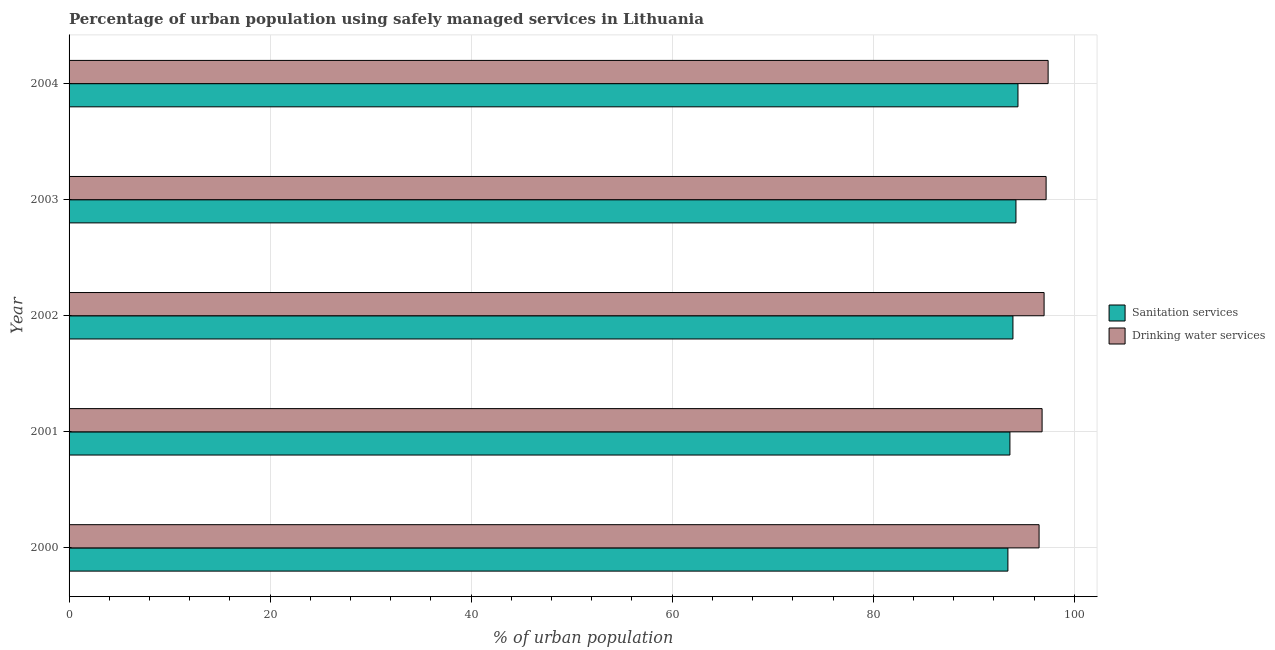How many different coloured bars are there?
Offer a very short reply. 2. How many groups of bars are there?
Make the answer very short. 5. What is the percentage of urban population who used sanitation services in 2002?
Make the answer very short. 93.9. Across all years, what is the maximum percentage of urban population who used drinking water services?
Provide a short and direct response. 97.4. Across all years, what is the minimum percentage of urban population who used drinking water services?
Provide a short and direct response. 96.5. What is the total percentage of urban population who used drinking water services in the graph?
Keep it short and to the point. 484.9. What is the difference between the percentage of urban population who used drinking water services in 2003 and that in 2004?
Ensure brevity in your answer.  -0.2. What is the difference between the percentage of urban population who used sanitation services in 2004 and the percentage of urban population who used drinking water services in 2003?
Offer a very short reply. -2.8. What is the average percentage of urban population who used drinking water services per year?
Offer a terse response. 96.98. In how many years, is the percentage of urban population who used sanitation services greater than 96 %?
Provide a short and direct response. 0. What is the ratio of the percentage of urban population who used sanitation services in 2001 to that in 2004?
Give a very brief answer. 0.99. Is the percentage of urban population who used drinking water services in 2000 less than that in 2001?
Keep it short and to the point. Yes. What is the difference between the highest and the second highest percentage of urban population who used drinking water services?
Offer a terse response. 0.2. What is the difference between the highest and the lowest percentage of urban population who used drinking water services?
Give a very brief answer. 0.9. Is the sum of the percentage of urban population who used drinking water services in 2000 and 2001 greater than the maximum percentage of urban population who used sanitation services across all years?
Your answer should be compact. Yes. What does the 2nd bar from the top in 2001 represents?
Ensure brevity in your answer.  Sanitation services. What does the 2nd bar from the bottom in 2001 represents?
Make the answer very short. Drinking water services. How many years are there in the graph?
Your answer should be compact. 5. What is the difference between two consecutive major ticks on the X-axis?
Offer a terse response. 20. Does the graph contain any zero values?
Offer a terse response. No. How many legend labels are there?
Your answer should be very brief. 2. How are the legend labels stacked?
Ensure brevity in your answer.  Vertical. What is the title of the graph?
Your answer should be compact. Percentage of urban population using safely managed services in Lithuania. Does "Start a business" appear as one of the legend labels in the graph?
Provide a succinct answer. No. What is the label or title of the X-axis?
Provide a short and direct response. % of urban population. What is the % of urban population in Sanitation services in 2000?
Provide a succinct answer. 93.4. What is the % of urban population in Drinking water services in 2000?
Your answer should be compact. 96.5. What is the % of urban population in Sanitation services in 2001?
Give a very brief answer. 93.6. What is the % of urban population in Drinking water services in 2001?
Provide a short and direct response. 96.8. What is the % of urban population in Sanitation services in 2002?
Your response must be concise. 93.9. What is the % of urban population of Drinking water services in 2002?
Your answer should be compact. 97. What is the % of urban population in Sanitation services in 2003?
Keep it short and to the point. 94.2. What is the % of urban population of Drinking water services in 2003?
Make the answer very short. 97.2. What is the % of urban population in Sanitation services in 2004?
Offer a very short reply. 94.4. What is the % of urban population in Drinking water services in 2004?
Provide a short and direct response. 97.4. Across all years, what is the maximum % of urban population of Sanitation services?
Your answer should be very brief. 94.4. Across all years, what is the maximum % of urban population in Drinking water services?
Keep it short and to the point. 97.4. Across all years, what is the minimum % of urban population in Sanitation services?
Provide a short and direct response. 93.4. Across all years, what is the minimum % of urban population in Drinking water services?
Your answer should be very brief. 96.5. What is the total % of urban population in Sanitation services in the graph?
Your answer should be very brief. 469.5. What is the total % of urban population of Drinking water services in the graph?
Your response must be concise. 484.9. What is the difference between the % of urban population in Sanitation services in 2000 and that in 2002?
Provide a succinct answer. -0.5. What is the difference between the % of urban population in Drinking water services in 2000 and that in 2002?
Provide a short and direct response. -0.5. What is the difference between the % of urban population in Drinking water services in 2000 and that in 2004?
Your answer should be compact. -0.9. What is the difference between the % of urban population of Sanitation services in 2001 and that in 2004?
Provide a short and direct response. -0.8. What is the difference between the % of urban population in Sanitation services in 2002 and that in 2003?
Offer a terse response. -0.3. What is the difference between the % of urban population of Drinking water services in 2002 and that in 2003?
Provide a succinct answer. -0.2. What is the difference between the % of urban population in Sanitation services in 2000 and the % of urban population in Drinking water services in 2002?
Give a very brief answer. -3.6. What is the difference between the % of urban population in Sanitation services in 2000 and the % of urban population in Drinking water services in 2003?
Provide a short and direct response. -3.8. What is the difference between the % of urban population in Sanitation services in 2001 and the % of urban population in Drinking water services in 2002?
Ensure brevity in your answer.  -3.4. What is the difference between the % of urban population in Sanitation services in 2002 and the % of urban population in Drinking water services in 2004?
Provide a succinct answer. -3.5. What is the average % of urban population in Sanitation services per year?
Offer a very short reply. 93.9. What is the average % of urban population of Drinking water services per year?
Make the answer very short. 96.98. In the year 2001, what is the difference between the % of urban population in Sanitation services and % of urban population in Drinking water services?
Keep it short and to the point. -3.2. In the year 2003, what is the difference between the % of urban population in Sanitation services and % of urban population in Drinking water services?
Make the answer very short. -3. In the year 2004, what is the difference between the % of urban population of Sanitation services and % of urban population of Drinking water services?
Offer a terse response. -3. What is the ratio of the % of urban population of Sanitation services in 2000 to that in 2001?
Ensure brevity in your answer.  1. What is the ratio of the % of urban population of Drinking water services in 2000 to that in 2001?
Ensure brevity in your answer.  1. What is the ratio of the % of urban population of Drinking water services in 2001 to that in 2002?
Provide a succinct answer. 1. What is the ratio of the % of urban population in Drinking water services in 2001 to that in 2003?
Your answer should be compact. 1. What is the ratio of the % of urban population of Sanitation services in 2002 to that in 2004?
Ensure brevity in your answer.  0.99. What is the ratio of the % of urban population in Drinking water services in 2002 to that in 2004?
Your answer should be compact. 1. What is the ratio of the % of urban population of Sanitation services in 2003 to that in 2004?
Your answer should be very brief. 1. What is the ratio of the % of urban population in Drinking water services in 2003 to that in 2004?
Your response must be concise. 1. What is the difference between the highest and the second highest % of urban population of Sanitation services?
Offer a very short reply. 0.2. What is the difference between the highest and the lowest % of urban population in Sanitation services?
Provide a succinct answer. 1. What is the difference between the highest and the lowest % of urban population in Drinking water services?
Keep it short and to the point. 0.9. 